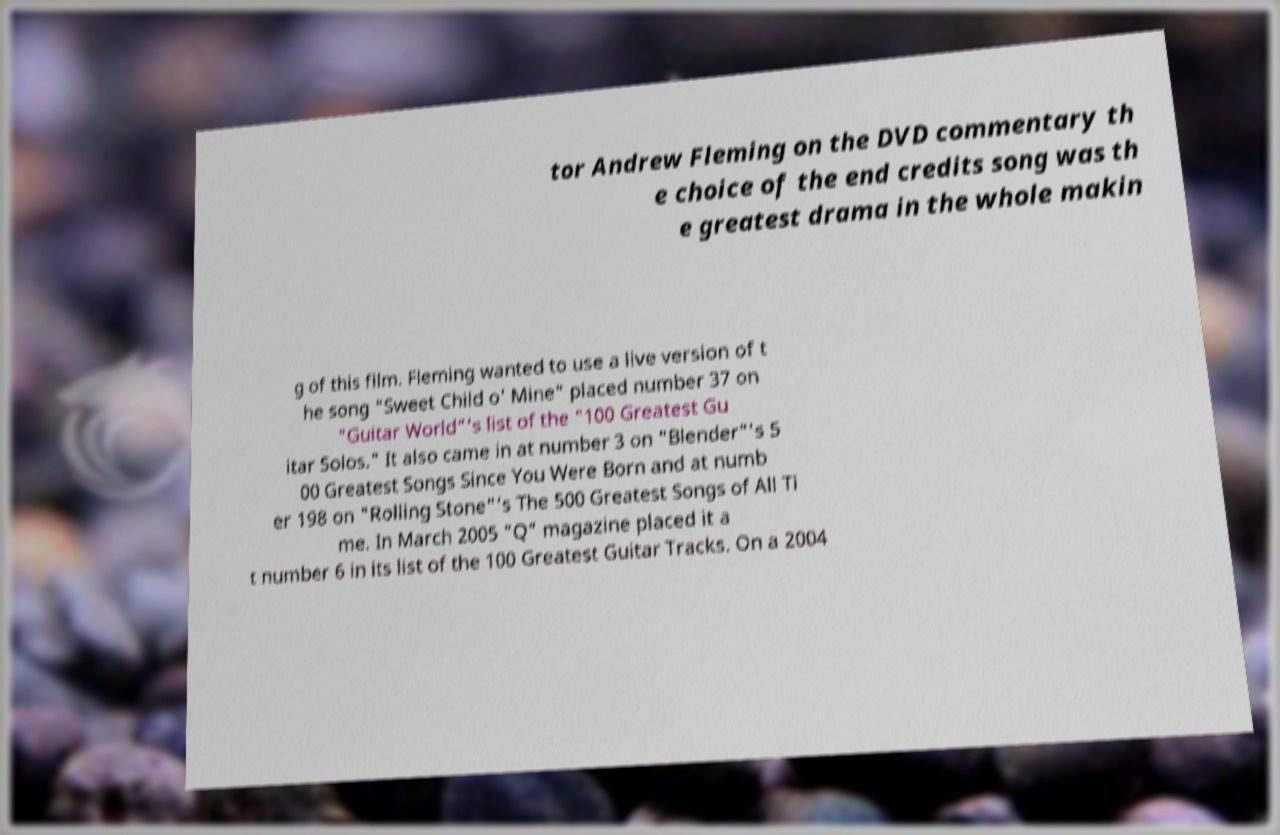Please read and relay the text visible in this image. What does it say? tor Andrew Fleming on the DVD commentary th e choice of the end credits song was th e greatest drama in the whole makin g of this film. Fleming wanted to use a live version of t he song "Sweet Child o' Mine" placed number 37 on "Guitar World"'s list of the "100 Greatest Gu itar Solos." It also came in at number 3 on "Blender"'s 5 00 Greatest Songs Since You Were Born and at numb er 198 on "Rolling Stone"'s The 500 Greatest Songs of All Ti me. In March 2005 "Q" magazine placed it a t number 6 in its list of the 100 Greatest Guitar Tracks. On a 2004 